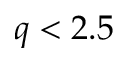<formula> <loc_0><loc_0><loc_500><loc_500>q < 2 . 5</formula> 